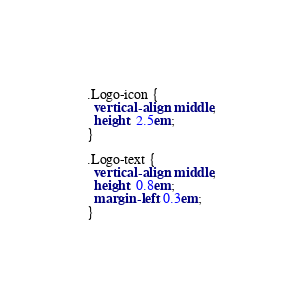Convert code to text. <code><loc_0><loc_0><loc_500><loc_500><_CSS_>.Logo-icon {
  vertical-align: middle;
  height: 2.5em;
}

.Logo-text {
  vertical-align: middle;
  height: 0.8em;
  margin-left: 0.3em;
}
</code> 